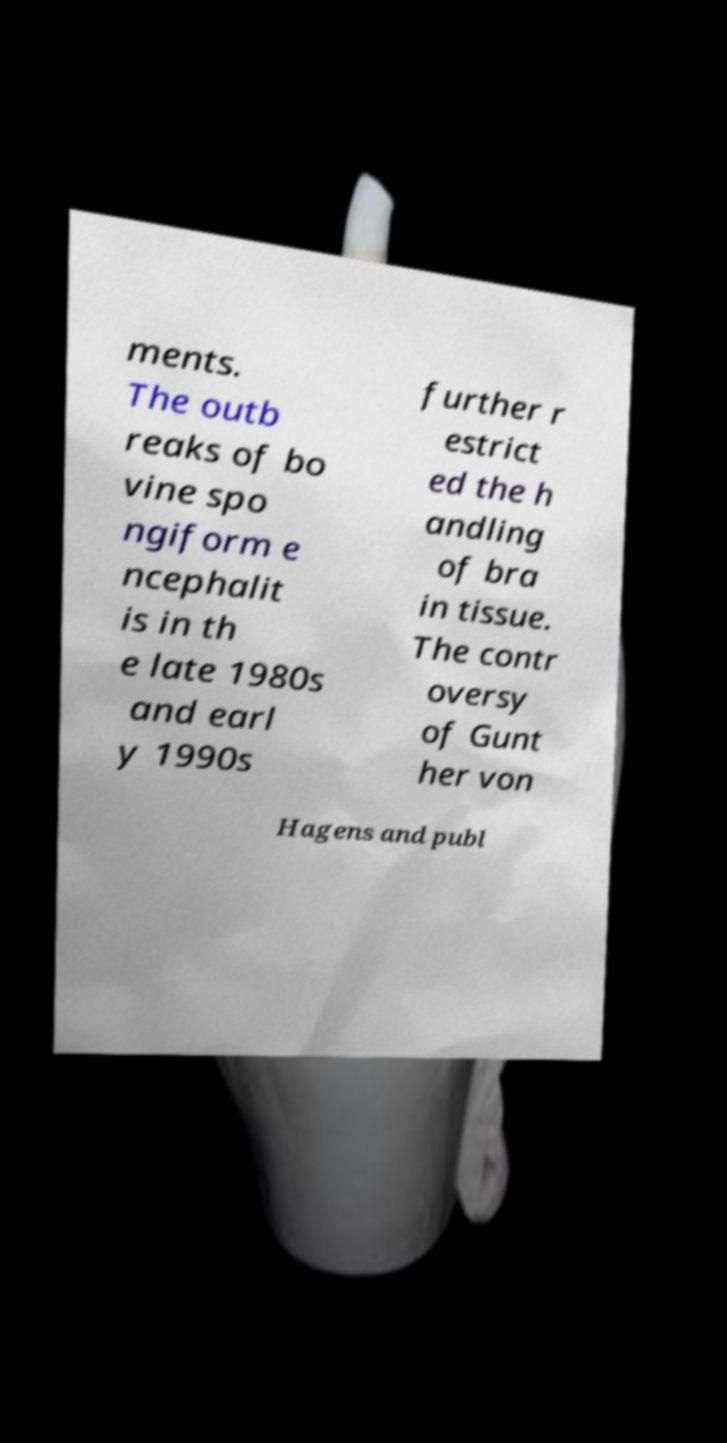There's text embedded in this image that I need extracted. Can you transcribe it verbatim? ments. The outb reaks of bo vine spo ngiform e ncephalit is in th e late 1980s and earl y 1990s further r estrict ed the h andling of bra in tissue. The contr oversy of Gunt her von Hagens and publ 